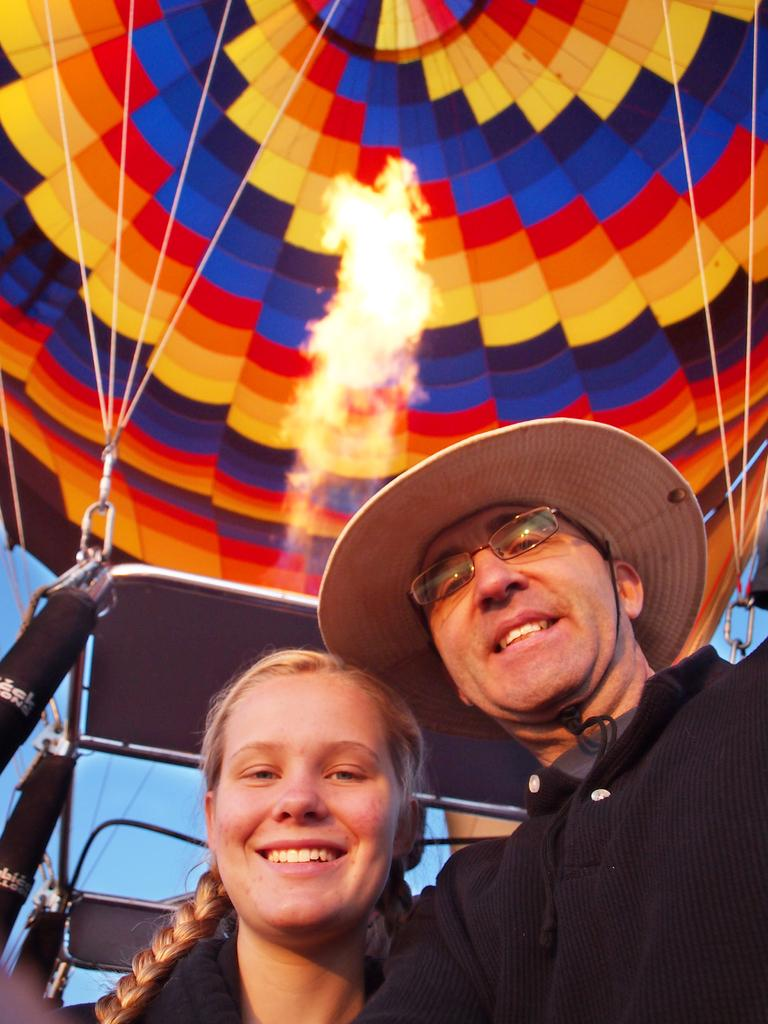How many people are present in the image? There are two people, a man and a woman, present in the image. What is the man wearing in the image? The man is wearing a black dress and a hat. What can be seen in the background of the image? There is an air balloon and the sky visible in the background of the image. What type of vein is visible on the woman's face in the image? There is no visible vein on the woman's face in the image. Did the man receive approval from the woman before wearing the hat in the image? There is no information about the man receiving approval from the woman in the image. 